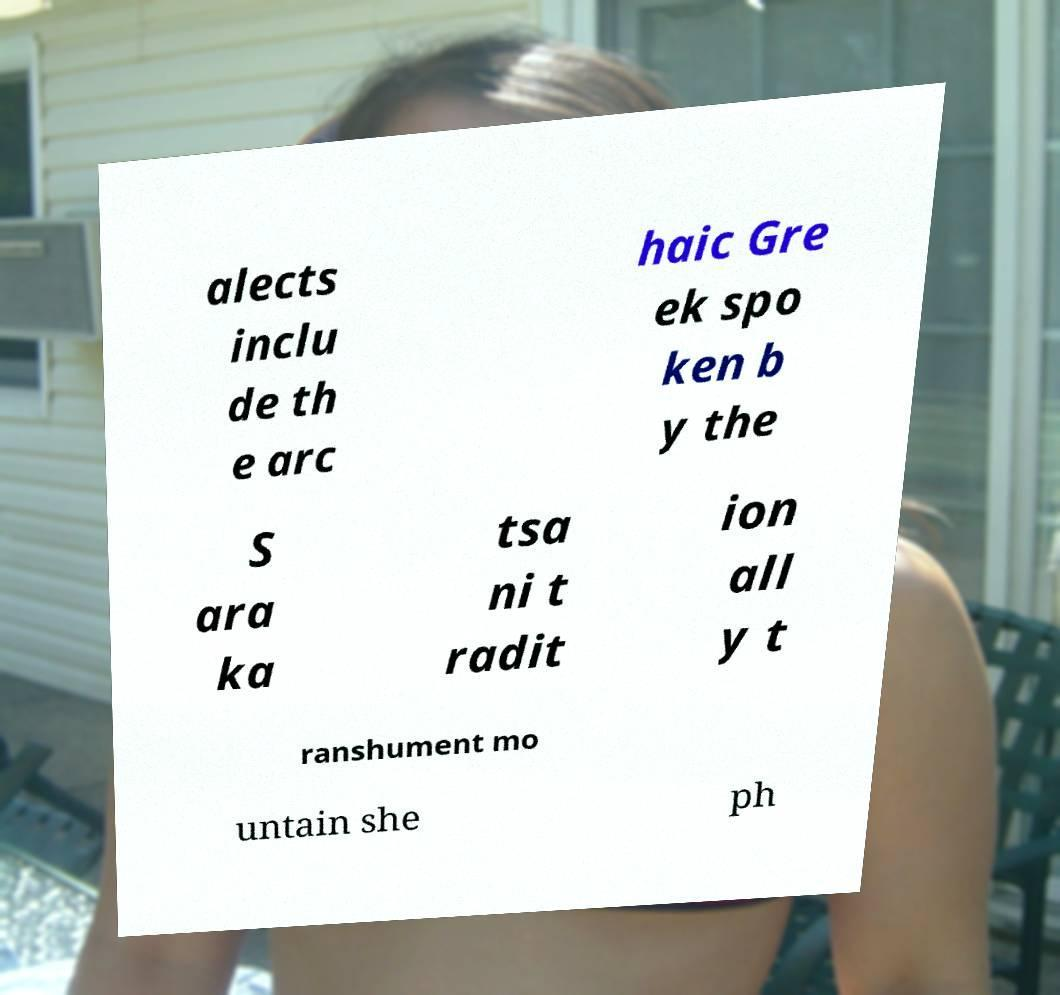Can you read and provide the text displayed in the image?This photo seems to have some interesting text. Can you extract and type it out for me? alects inclu de th e arc haic Gre ek spo ken b y the S ara ka tsa ni t radit ion all y t ranshument mo untain she ph 